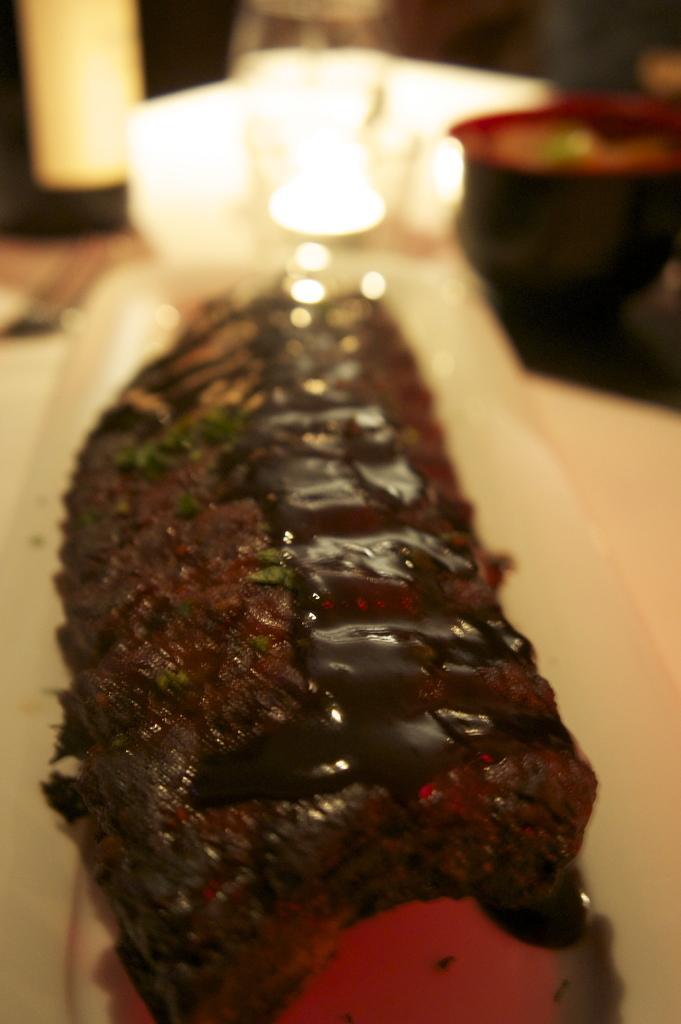In one or two sentences, can you explain what this image depicts? In this image there is a food item in a plate, in the background it is blurred. 